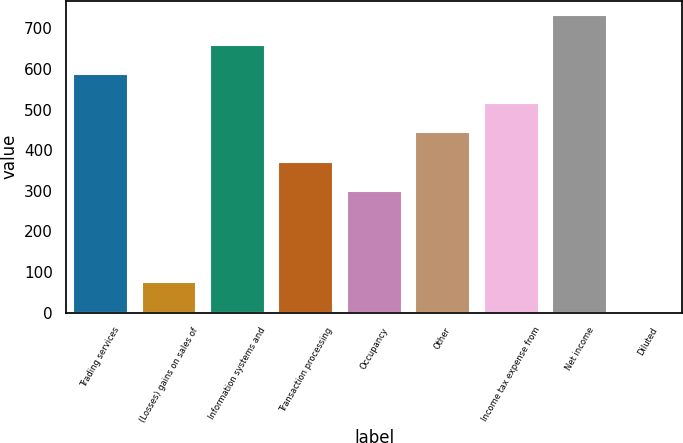<chart> <loc_0><loc_0><loc_500><loc_500><bar_chart><fcel>Trading services<fcel>(Losses) gains on sales of<fcel>Information systems and<fcel>Transaction processing<fcel>Occupancy<fcel>Other<fcel>Income tax expense from<fcel>Net income<fcel>Diluted<nl><fcel>587.96<fcel>74.14<fcel>659.95<fcel>371.99<fcel>300<fcel>443.98<fcel>515.97<fcel>731.94<fcel>2.15<nl></chart> 